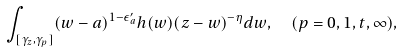Convert formula to latex. <formula><loc_0><loc_0><loc_500><loc_500>& \int _ { [ \gamma _ { z } , \gamma _ { p } ] } ( w - a ) ^ { 1 - \epsilon ^ { \prime } _ { a } } h ( w ) ( z - w ) ^ { - \eta } d w , \quad ( p = 0 , 1 , t , \infty ) ,</formula> 